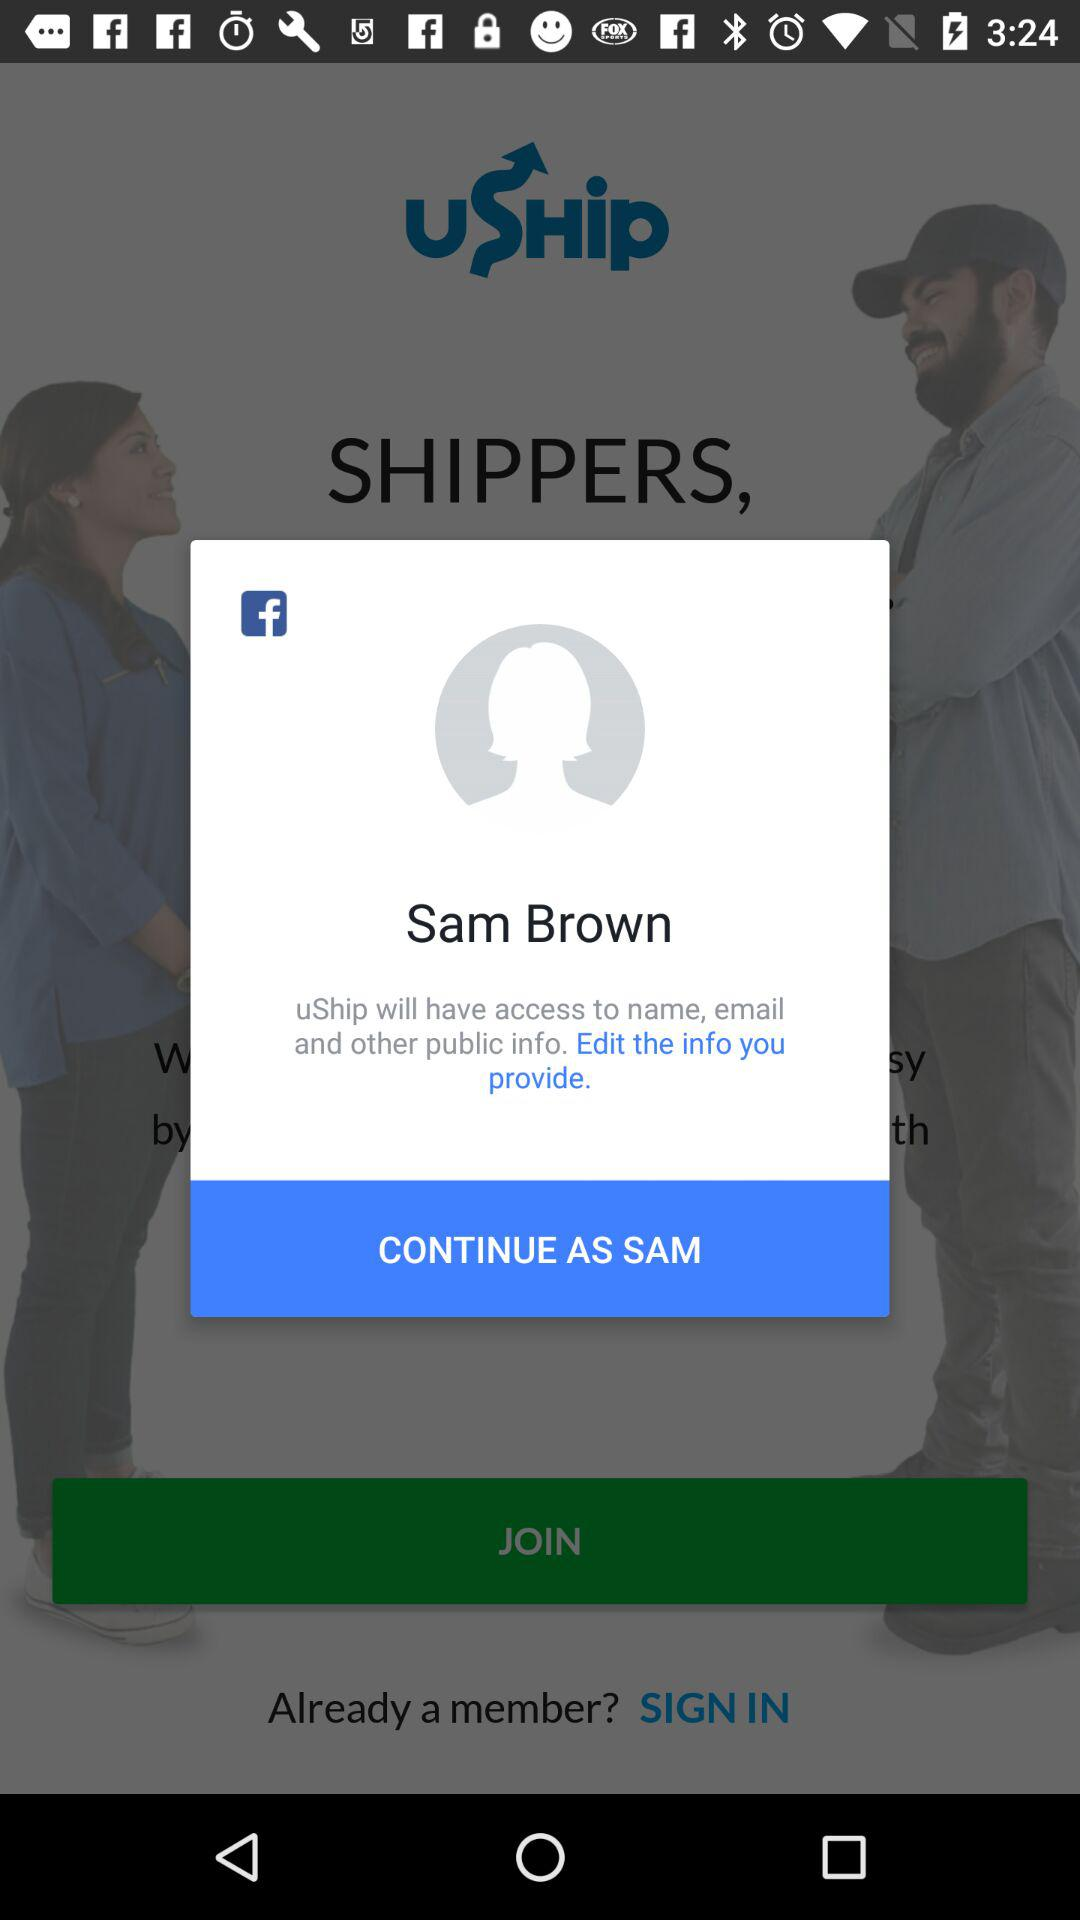Through what application can a user continue with? The application is "Facebook". 